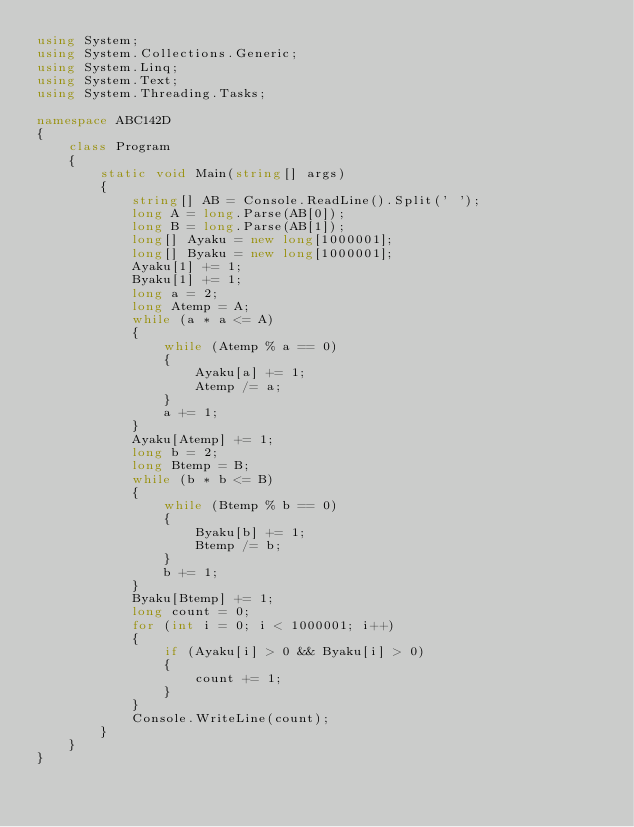<code> <loc_0><loc_0><loc_500><loc_500><_C#_>using System;
using System.Collections.Generic;
using System.Linq;
using System.Text;
using System.Threading.Tasks;

namespace ABC142D
{
    class Program
    {
        static void Main(string[] args)
        {
            string[] AB = Console.ReadLine().Split(' ');
            long A = long.Parse(AB[0]);
            long B = long.Parse(AB[1]);
            long[] Ayaku = new long[1000001];
            long[] Byaku = new long[1000001];
            Ayaku[1] += 1;
            Byaku[1] += 1;
            long a = 2;
            long Atemp = A;
            while (a * a <= A)
            {
                while (Atemp % a == 0)
                {
                    Ayaku[a] += 1;
                    Atemp /= a;
                }
                a += 1;
            }
            Ayaku[Atemp] += 1;
            long b = 2;
            long Btemp = B;
            while (b * b <= B)
            {
                while (Btemp % b == 0)
                {
                    Byaku[b] += 1;
                    Btemp /= b;
                }
                b += 1;
            }
            Byaku[Btemp] += 1;
            long count = 0;
            for (int i = 0; i < 1000001; i++)
            {
                if (Ayaku[i] > 0 && Byaku[i] > 0)
                {
                    count += 1;
                }
            }
            Console.WriteLine(count);
        }
    }
}
</code> 